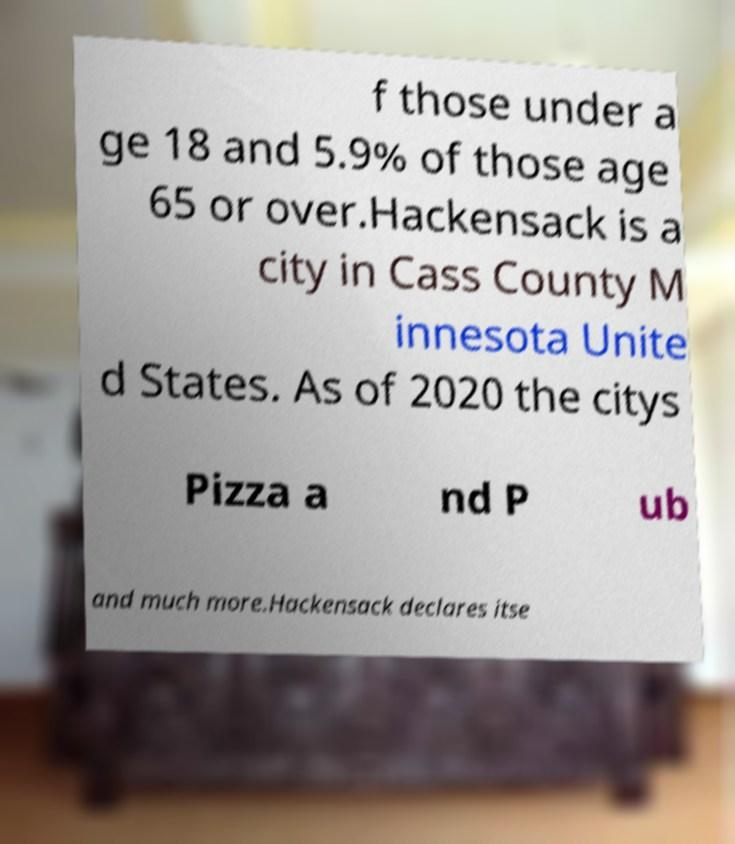I need the written content from this picture converted into text. Can you do that? f those under a ge 18 and 5.9% of those age 65 or over.Hackensack is a city in Cass County M innesota Unite d States. As of 2020 the citys Pizza a nd P ub and much more.Hackensack declares itse 